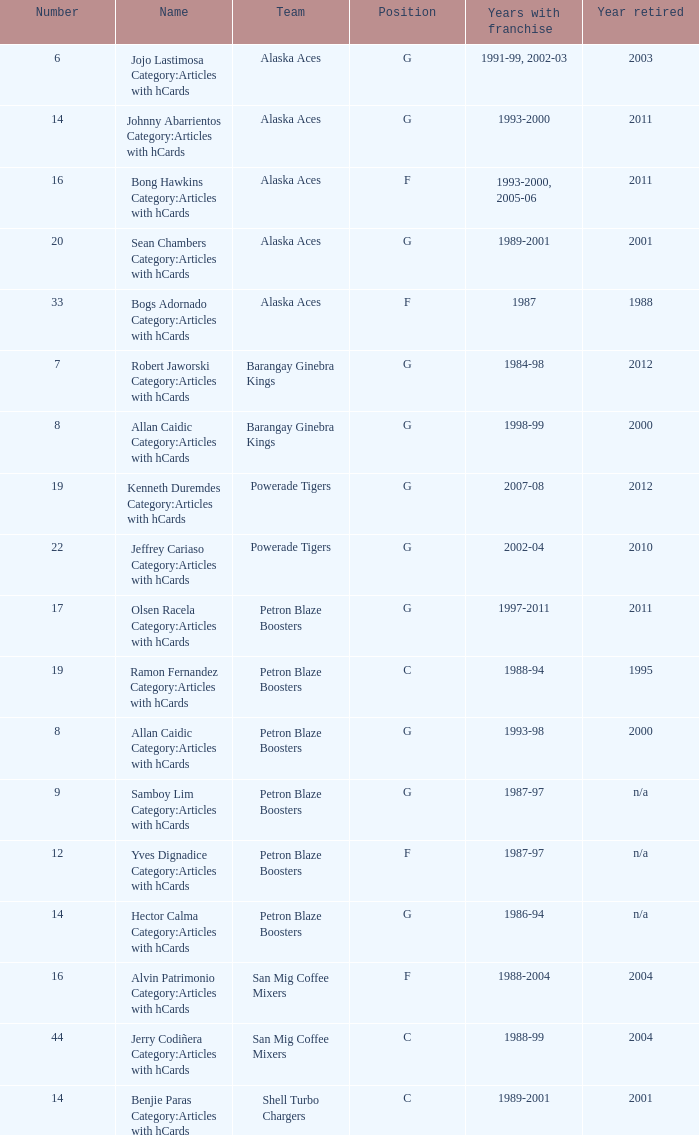Which 14th-ranked team had a franchise in the time span of 1993 to 2000? Alaska Aces. Can you parse all the data within this table? {'header': ['Number', 'Name', 'Team', 'Position', 'Years with franchise', 'Year retired'], 'rows': [['6', 'Jojo Lastimosa Category:Articles with hCards', 'Alaska Aces', 'G', '1991-99, 2002-03', '2003'], ['14', 'Johnny Abarrientos Category:Articles with hCards', 'Alaska Aces', 'G', '1993-2000', '2011'], ['16', 'Bong Hawkins Category:Articles with hCards', 'Alaska Aces', 'F', '1993-2000, 2005-06', '2011'], ['20', 'Sean Chambers Category:Articles with hCards', 'Alaska Aces', 'G', '1989-2001', '2001'], ['33', 'Bogs Adornado Category:Articles with hCards', 'Alaska Aces', 'F', '1987', '1988'], ['7', 'Robert Jaworski Category:Articles with hCards', 'Barangay Ginebra Kings', 'G', '1984-98', '2012'], ['8', 'Allan Caidic Category:Articles with hCards', 'Barangay Ginebra Kings', 'G', '1998-99', '2000'], ['19', 'Kenneth Duremdes Category:Articles with hCards', 'Powerade Tigers', 'G', '2007-08', '2012'], ['22', 'Jeffrey Cariaso Category:Articles with hCards', 'Powerade Tigers', 'G', '2002-04', '2010'], ['17', 'Olsen Racela Category:Articles with hCards', 'Petron Blaze Boosters', 'G', '1997-2011', '2011'], ['19', 'Ramon Fernandez Category:Articles with hCards', 'Petron Blaze Boosters', 'C', '1988-94', '1995'], ['8', 'Allan Caidic Category:Articles with hCards', 'Petron Blaze Boosters', 'G', '1993-98', '2000'], ['9', 'Samboy Lim Category:Articles with hCards', 'Petron Blaze Boosters', 'G', '1987-97', 'n/a'], ['12', 'Yves Dignadice Category:Articles with hCards', 'Petron Blaze Boosters', 'F', '1987-97', 'n/a'], ['14', 'Hector Calma Category:Articles with hCards', 'Petron Blaze Boosters', 'G', '1986-94', 'n/a'], ['16', 'Alvin Patrimonio Category:Articles with hCards', 'San Mig Coffee Mixers', 'F', '1988-2004', '2004'], ['44', 'Jerry Codiñera Category:Articles with hCards', 'San Mig Coffee Mixers', 'C', '1988-99', '2004'], ['14', 'Benjie Paras Category:Articles with hCards', 'Shell Turbo Chargers', 'C', '1989-2001', '2001']]} 